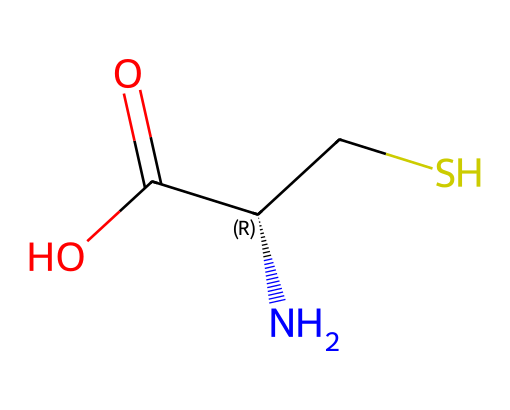What is the chemical name of the structure shown? The SMILES representation indicates it is Cysteine, which is a known amino acid with the chemical formula given by its SMILES notation.
Answer: Cysteine How many carbon atoms are present in the structure? The SMILES shows three distinct carbon atoms in the main chain, specifically the second carbon is part of the sulfhydryl group.
Answer: 3 What type of functional group is present in this chemical? The molecule contains a sulfhydryl group, denoted by "SH" in the structure, characteristic of organosulfur compounds.
Answer: Sulfhydryl What is the total number of hydrogen atoms in this structure? By examining the SMILES notation, we can identify the associated hydrogen atoms. Cysteine has an overall composition of 7 hydrogen atoms when considering its groups and carbon saturation.
Answer: 7 What is the significance of the sulfur atom in cysteine? The sulfur atom contributes to the formation of disulfide bonds, which are crucial for the tertiary structure of proteins, enhancing stability and function.
Answer: Disulfide bonds How many stereocenters are present in this molecule? Analyzing the structure, we observe one stereocenter (the chiral carbon), which is noted by the '@' symbol in the SMILES notation.
Answer: 1 What is cysteine's role in protein structure? Cysteine's sulfhydryl group allows it to form various bonds, specifically disulfide bridges, which help maintain the three-dimensional shape of proteins, crucial for their function.
Answer: Disulfide bridges 